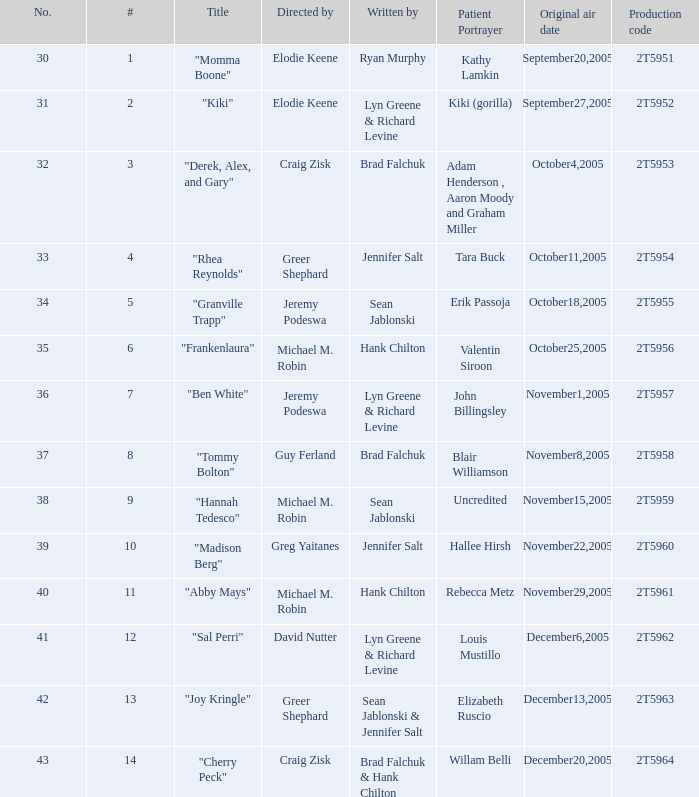What is the total number of patient portayers for the episode directed by Craig Zisk and written by Brad Falchuk? 1.0. 